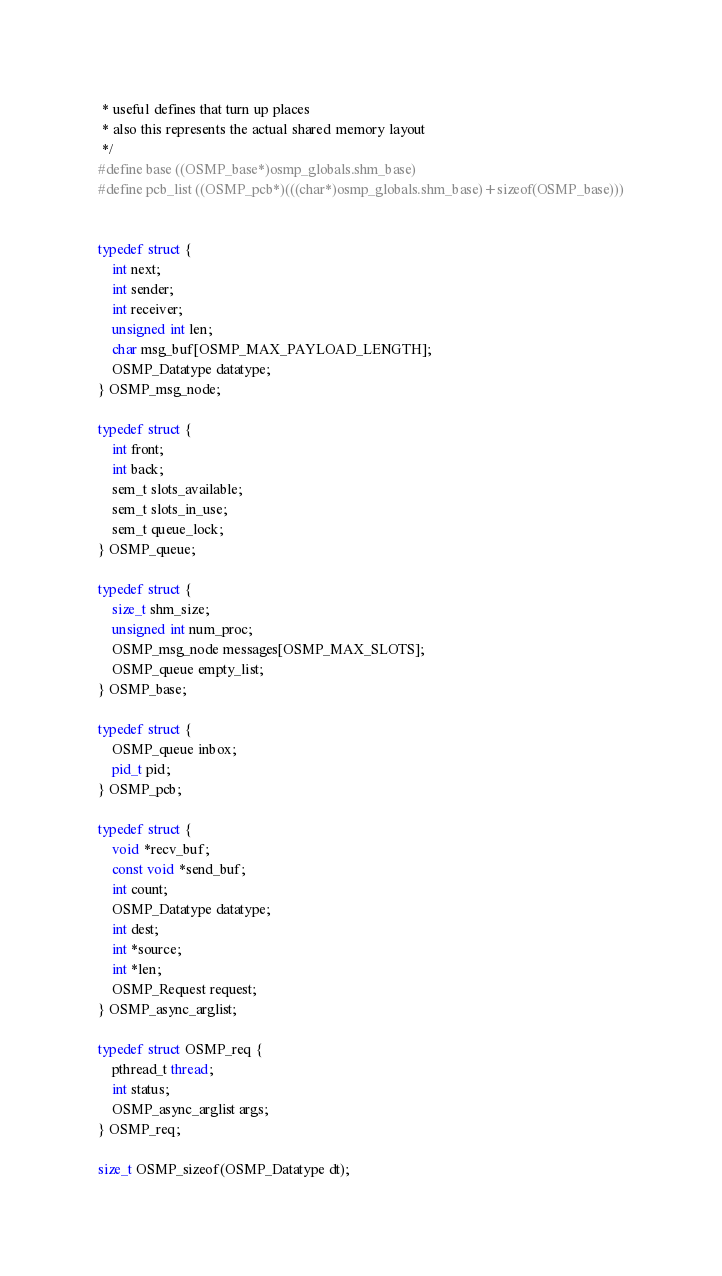Convert code to text. <code><loc_0><loc_0><loc_500><loc_500><_C_> * useful defines that turn up places 
 * also this represents the actual shared memory layout 
 */
#define base ((OSMP_base*)osmp_globals.shm_base)
#define pcb_list ((OSMP_pcb*)(((char*)osmp_globals.shm_base)+sizeof(OSMP_base)))


typedef struct {
    int next;
    int sender;
    int receiver;
    unsigned int len;
    char msg_buf[OSMP_MAX_PAYLOAD_LENGTH];
    OSMP_Datatype datatype;
} OSMP_msg_node;

typedef struct {
    int front;
    int back;
    sem_t slots_available;
    sem_t slots_in_use;
    sem_t queue_lock;
} OSMP_queue;

typedef struct {
    size_t shm_size;
    unsigned int num_proc;
    OSMP_msg_node messages[OSMP_MAX_SLOTS];
    OSMP_queue empty_list;
} OSMP_base;

typedef struct {
    OSMP_queue inbox;
    pid_t pid;
} OSMP_pcb;

typedef struct {
    void *recv_buf;
    const void *send_buf;
    int count;
    OSMP_Datatype datatype;
    int dest;
    int *source;
    int *len;
    OSMP_Request request;
} OSMP_async_arglist;

typedef struct OSMP_req {
    pthread_t thread;
    int status;
    OSMP_async_arglist args;
} OSMP_req;

size_t OSMP_sizeof(OSMP_Datatype dt);
</code> 